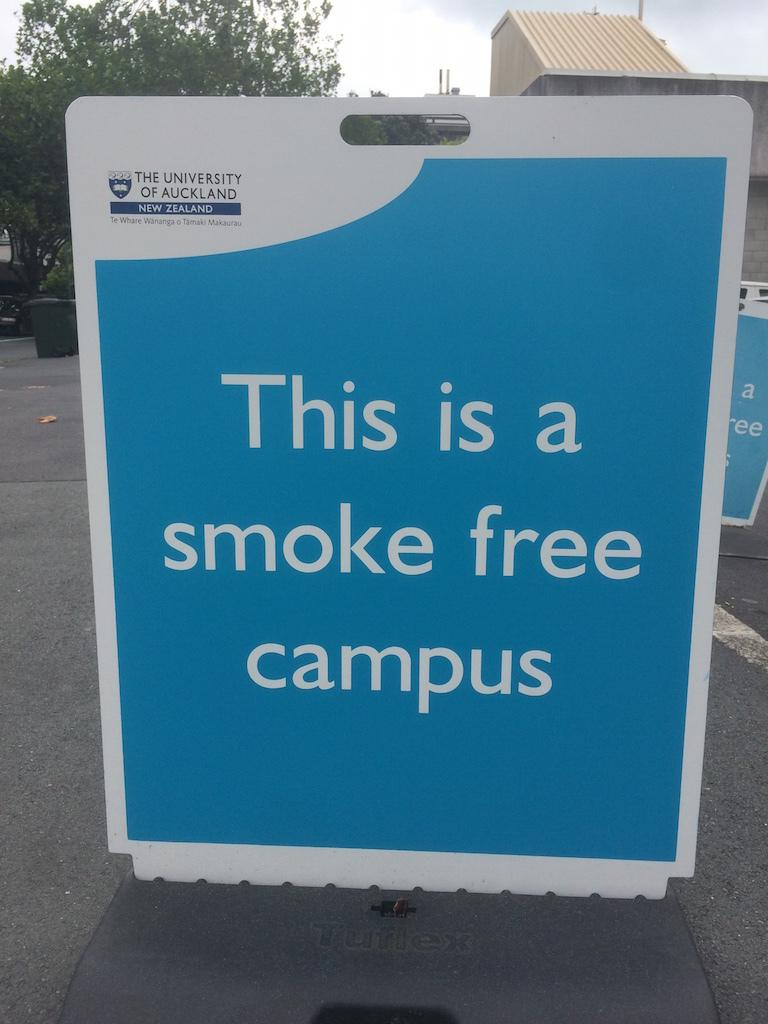<image>
Create a compact narrative representing the image presented. One is not allowed to smoke at this particular school. 